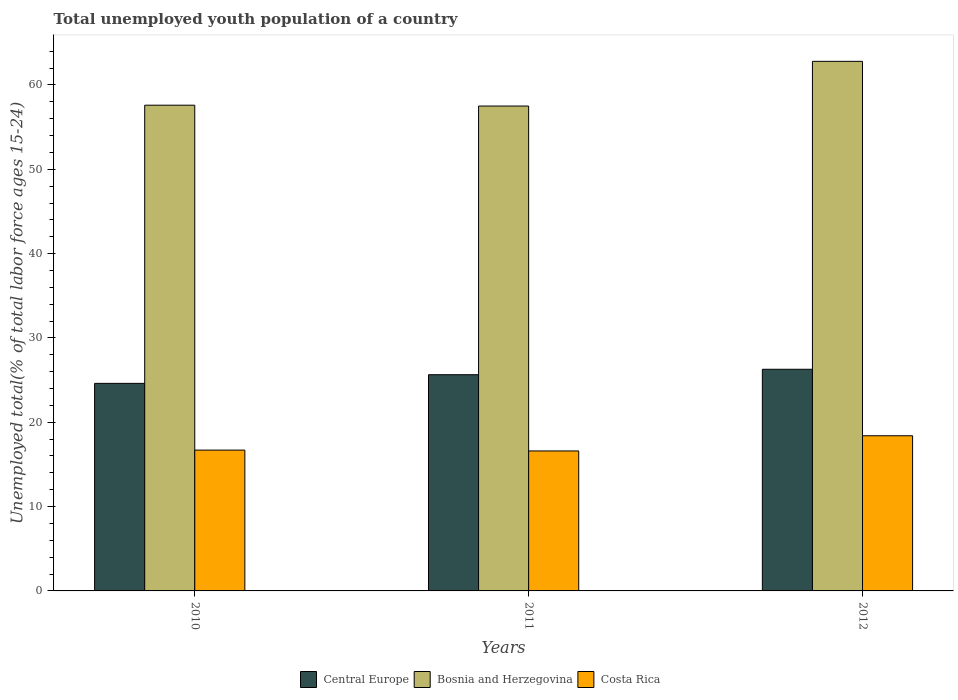How many different coloured bars are there?
Offer a terse response. 3. Are the number of bars per tick equal to the number of legend labels?
Give a very brief answer. Yes. How many bars are there on the 3rd tick from the right?
Your answer should be very brief. 3. What is the label of the 3rd group of bars from the left?
Ensure brevity in your answer.  2012. In how many cases, is the number of bars for a given year not equal to the number of legend labels?
Provide a short and direct response. 0. What is the percentage of total unemployed youth population of a country in Costa Rica in 2012?
Your answer should be very brief. 18.4. Across all years, what is the maximum percentage of total unemployed youth population of a country in Bosnia and Herzegovina?
Your response must be concise. 62.8. Across all years, what is the minimum percentage of total unemployed youth population of a country in Costa Rica?
Provide a succinct answer. 16.6. In which year was the percentage of total unemployed youth population of a country in Bosnia and Herzegovina maximum?
Your response must be concise. 2012. In which year was the percentage of total unemployed youth population of a country in Central Europe minimum?
Give a very brief answer. 2010. What is the total percentage of total unemployed youth population of a country in Central Europe in the graph?
Your response must be concise. 76.54. What is the difference between the percentage of total unemployed youth population of a country in Costa Rica in 2011 and that in 2012?
Offer a very short reply. -1.8. What is the difference between the percentage of total unemployed youth population of a country in Central Europe in 2011 and the percentage of total unemployed youth population of a country in Costa Rica in 2010?
Provide a succinct answer. 8.94. What is the average percentage of total unemployed youth population of a country in Bosnia and Herzegovina per year?
Ensure brevity in your answer.  59.3. In the year 2010, what is the difference between the percentage of total unemployed youth population of a country in Costa Rica and percentage of total unemployed youth population of a country in Bosnia and Herzegovina?
Your answer should be compact. -40.9. What is the ratio of the percentage of total unemployed youth population of a country in Bosnia and Herzegovina in 2010 to that in 2011?
Provide a succinct answer. 1. Is the difference between the percentage of total unemployed youth population of a country in Costa Rica in 2010 and 2012 greater than the difference between the percentage of total unemployed youth population of a country in Bosnia and Herzegovina in 2010 and 2012?
Your answer should be compact. Yes. What is the difference between the highest and the second highest percentage of total unemployed youth population of a country in Bosnia and Herzegovina?
Provide a short and direct response. 5.2. What is the difference between the highest and the lowest percentage of total unemployed youth population of a country in Bosnia and Herzegovina?
Provide a succinct answer. 5.3. Is the sum of the percentage of total unemployed youth population of a country in Bosnia and Herzegovina in 2010 and 2011 greater than the maximum percentage of total unemployed youth population of a country in Costa Rica across all years?
Your answer should be compact. Yes. What does the 3rd bar from the right in 2012 represents?
Offer a terse response. Central Europe. Is it the case that in every year, the sum of the percentage of total unemployed youth population of a country in Central Europe and percentage of total unemployed youth population of a country in Costa Rica is greater than the percentage of total unemployed youth population of a country in Bosnia and Herzegovina?
Provide a short and direct response. No. How many bars are there?
Keep it short and to the point. 9. How many years are there in the graph?
Your answer should be compact. 3. Are the values on the major ticks of Y-axis written in scientific E-notation?
Your response must be concise. No. Does the graph contain grids?
Provide a succinct answer. No. How many legend labels are there?
Your answer should be compact. 3. How are the legend labels stacked?
Your answer should be compact. Horizontal. What is the title of the graph?
Give a very brief answer. Total unemployed youth population of a country. Does "Bosnia and Herzegovina" appear as one of the legend labels in the graph?
Provide a succinct answer. Yes. What is the label or title of the X-axis?
Provide a succinct answer. Years. What is the label or title of the Y-axis?
Provide a succinct answer. Unemployed total(% of total labor force ages 15-24). What is the Unemployed total(% of total labor force ages 15-24) in Central Europe in 2010?
Provide a short and direct response. 24.61. What is the Unemployed total(% of total labor force ages 15-24) in Bosnia and Herzegovina in 2010?
Ensure brevity in your answer.  57.6. What is the Unemployed total(% of total labor force ages 15-24) of Costa Rica in 2010?
Offer a terse response. 16.7. What is the Unemployed total(% of total labor force ages 15-24) of Central Europe in 2011?
Offer a terse response. 25.64. What is the Unemployed total(% of total labor force ages 15-24) in Bosnia and Herzegovina in 2011?
Provide a succinct answer. 57.5. What is the Unemployed total(% of total labor force ages 15-24) in Costa Rica in 2011?
Offer a very short reply. 16.6. What is the Unemployed total(% of total labor force ages 15-24) in Central Europe in 2012?
Ensure brevity in your answer.  26.29. What is the Unemployed total(% of total labor force ages 15-24) in Bosnia and Herzegovina in 2012?
Provide a succinct answer. 62.8. What is the Unemployed total(% of total labor force ages 15-24) in Costa Rica in 2012?
Provide a succinct answer. 18.4. Across all years, what is the maximum Unemployed total(% of total labor force ages 15-24) of Central Europe?
Offer a very short reply. 26.29. Across all years, what is the maximum Unemployed total(% of total labor force ages 15-24) of Bosnia and Herzegovina?
Make the answer very short. 62.8. Across all years, what is the maximum Unemployed total(% of total labor force ages 15-24) in Costa Rica?
Your answer should be compact. 18.4. Across all years, what is the minimum Unemployed total(% of total labor force ages 15-24) in Central Europe?
Keep it short and to the point. 24.61. Across all years, what is the minimum Unemployed total(% of total labor force ages 15-24) of Bosnia and Herzegovina?
Your response must be concise. 57.5. Across all years, what is the minimum Unemployed total(% of total labor force ages 15-24) in Costa Rica?
Your answer should be compact. 16.6. What is the total Unemployed total(% of total labor force ages 15-24) of Central Europe in the graph?
Offer a very short reply. 76.54. What is the total Unemployed total(% of total labor force ages 15-24) in Bosnia and Herzegovina in the graph?
Offer a very short reply. 177.9. What is the total Unemployed total(% of total labor force ages 15-24) of Costa Rica in the graph?
Offer a very short reply. 51.7. What is the difference between the Unemployed total(% of total labor force ages 15-24) in Central Europe in 2010 and that in 2011?
Offer a very short reply. -1.03. What is the difference between the Unemployed total(% of total labor force ages 15-24) in Costa Rica in 2010 and that in 2011?
Keep it short and to the point. 0.1. What is the difference between the Unemployed total(% of total labor force ages 15-24) in Central Europe in 2010 and that in 2012?
Keep it short and to the point. -1.67. What is the difference between the Unemployed total(% of total labor force ages 15-24) of Costa Rica in 2010 and that in 2012?
Keep it short and to the point. -1.7. What is the difference between the Unemployed total(% of total labor force ages 15-24) of Central Europe in 2011 and that in 2012?
Ensure brevity in your answer.  -0.65. What is the difference between the Unemployed total(% of total labor force ages 15-24) of Costa Rica in 2011 and that in 2012?
Provide a short and direct response. -1.8. What is the difference between the Unemployed total(% of total labor force ages 15-24) of Central Europe in 2010 and the Unemployed total(% of total labor force ages 15-24) of Bosnia and Herzegovina in 2011?
Ensure brevity in your answer.  -32.89. What is the difference between the Unemployed total(% of total labor force ages 15-24) in Central Europe in 2010 and the Unemployed total(% of total labor force ages 15-24) in Costa Rica in 2011?
Ensure brevity in your answer.  8.01. What is the difference between the Unemployed total(% of total labor force ages 15-24) in Bosnia and Herzegovina in 2010 and the Unemployed total(% of total labor force ages 15-24) in Costa Rica in 2011?
Offer a terse response. 41. What is the difference between the Unemployed total(% of total labor force ages 15-24) of Central Europe in 2010 and the Unemployed total(% of total labor force ages 15-24) of Bosnia and Herzegovina in 2012?
Your response must be concise. -38.19. What is the difference between the Unemployed total(% of total labor force ages 15-24) of Central Europe in 2010 and the Unemployed total(% of total labor force ages 15-24) of Costa Rica in 2012?
Provide a short and direct response. 6.21. What is the difference between the Unemployed total(% of total labor force ages 15-24) in Bosnia and Herzegovina in 2010 and the Unemployed total(% of total labor force ages 15-24) in Costa Rica in 2012?
Keep it short and to the point. 39.2. What is the difference between the Unemployed total(% of total labor force ages 15-24) in Central Europe in 2011 and the Unemployed total(% of total labor force ages 15-24) in Bosnia and Herzegovina in 2012?
Offer a very short reply. -37.16. What is the difference between the Unemployed total(% of total labor force ages 15-24) in Central Europe in 2011 and the Unemployed total(% of total labor force ages 15-24) in Costa Rica in 2012?
Keep it short and to the point. 7.24. What is the difference between the Unemployed total(% of total labor force ages 15-24) of Bosnia and Herzegovina in 2011 and the Unemployed total(% of total labor force ages 15-24) of Costa Rica in 2012?
Ensure brevity in your answer.  39.1. What is the average Unemployed total(% of total labor force ages 15-24) of Central Europe per year?
Your response must be concise. 25.51. What is the average Unemployed total(% of total labor force ages 15-24) of Bosnia and Herzegovina per year?
Give a very brief answer. 59.3. What is the average Unemployed total(% of total labor force ages 15-24) of Costa Rica per year?
Offer a very short reply. 17.23. In the year 2010, what is the difference between the Unemployed total(% of total labor force ages 15-24) of Central Europe and Unemployed total(% of total labor force ages 15-24) of Bosnia and Herzegovina?
Offer a terse response. -32.99. In the year 2010, what is the difference between the Unemployed total(% of total labor force ages 15-24) in Central Europe and Unemployed total(% of total labor force ages 15-24) in Costa Rica?
Offer a very short reply. 7.91. In the year 2010, what is the difference between the Unemployed total(% of total labor force ages 15-24) of Bosnia and Herzegovina and Unemployed total(% of total labor force ages 15-24) of Costa Rica?
Offer a terse response. 40.9. In the year 2011, what is the difference between the Unemployed total(% of total labor force ages 15-24) of Central Europe and Unemployed total(% of total labor force ages 15-24) of Bosnia and Herzegovina?
Your answer should be compact. -31.86. In the year 2011, what is the difference between the Unemployed total(% of total labor force ages 15-24) of Central Europe and Unemployed total(% of total labor force ages 15-24) of Costa Rica?
Provide a short and direct response. 9.04. In the year 2011, what is the difference between the Unemployed total(% of total labor force ages 15-24) in Bosnia and Herzegovina and Unemployed total(% of total labor force ages 15-24) in Costa Rica?
Your response must be concise. 40.9. In the year 2012, what is the difference between the Unemployed total(% of total labor force ages 15-24) of Central Europe and Unemployed total(% of total labor force ages 15-24) of Bosnia and Herzegovina?
Keep it short and to the point. -36.51. In the year 2012, what is the difference between the Unemployed total(% of total labor force ages 15-24) in Central Europe and Unemployed total(% of total labor force ages 15-24) in Costa Rica?
Keep it short and to the point. 7.89. In the year 2012, what is the difference between the Unemployed total(% of total labor force ages 15-24) in Bosnia and Herzegovina and Unemployed total(% of total labor force ages 15-24) in Costa Rica?
Give a very brief answer. 44.4. What is the ratio of the Unemployed total(% of total labor force ages 15-24) of Bosnia and Herzegovina in 2010 to that in 2011?
Make the answer very short. 1. What is the ratio of the Unemployed total(% of total labor force ages 15-24) of Costa Rica in 2010 to that in 2011?
Ensure brevity in your answer.  1.01. What is the ratio of the Unemployed total(% of total labor force ages 15-24) of Central Europe in 2010 to that in 2012?
Your answer should be very brief. 0.94. What is the ratio of the Unemployed total(% of total labor force ages 15-24) in Bosnia and Herzegovina in 2010 to that in 2012?
Your answer should be very brief. 0.92. What is the ratio of the Unemployed total(% of total labor force ages 15-24) of Costa Rica in 2010 to that in 2012?
Give a very brief answer. 0.91. What is the ratio of the Unemployed total(% of total labor force ages 15-24) of Central Europe in 2011 to that in 2012?
Keep it short and to the point. 0.98. What is the ratio of the Unemployed total(% of total labor force ages 15-24) of Bosnia and Herzegovina in 2011 to that in 2012?
Your answer should be compact. 0.92. What is the ratio of the Unemployed total(% of total labor force ages 15-24) of Costa Rica in 2011 to that in 2012?
Offer a terse response. 0.9. What is the difference between the highest and the second highest Unemployed total(% of total labor force ages 15-24) of Central Europe?
Make the answer very short. 0.65. What is the difference between the highest and the second highest Unemployed total(% of total labor force ages 15-24) of Costa Rica?
Offer a very short reply. 1.7. What is the difference between the highest and the lowest Unemployed total(% of total labor force ages 15-24) in Central Europe?
Your answer should be compact. 1.67. What is the difference between the highest and the lowest Unemployed total(% of total labor force ages 15-24) in Costa Rica?
Keep it short and to the point. 1.8. 